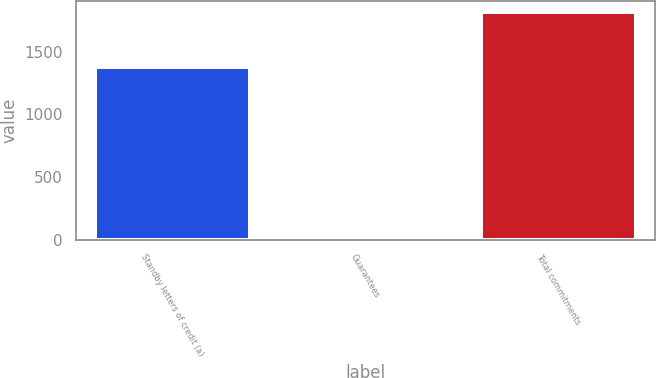Convert chart. <chart><loc_0><loc_0><loc_500><loc_500><bar_chart><fcel>Standby letters of credit (a)<fcel>Guarantees<fcel>Total commitments<nl><fcel>1374<fcel>21<fcel>1815<nl></chart> 